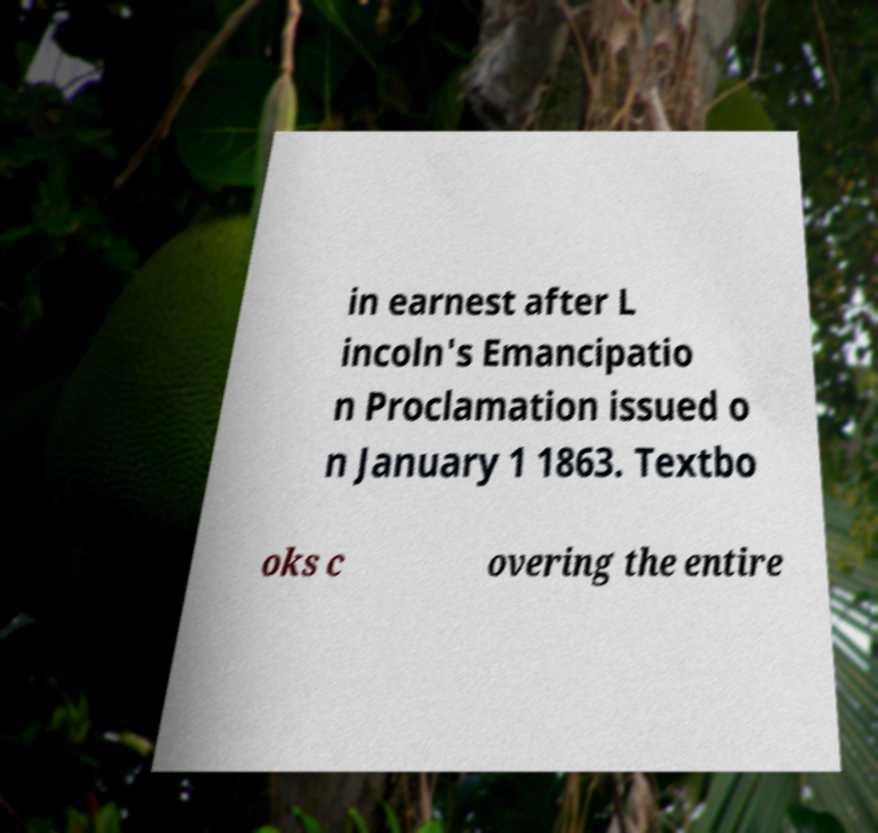Could you assist in decoding the text presented in this image and type it out clearly? in earnest after L incoln's Emancipatio n Proclamation issued o n January 1 1863. Textbo oks c overing the entire 